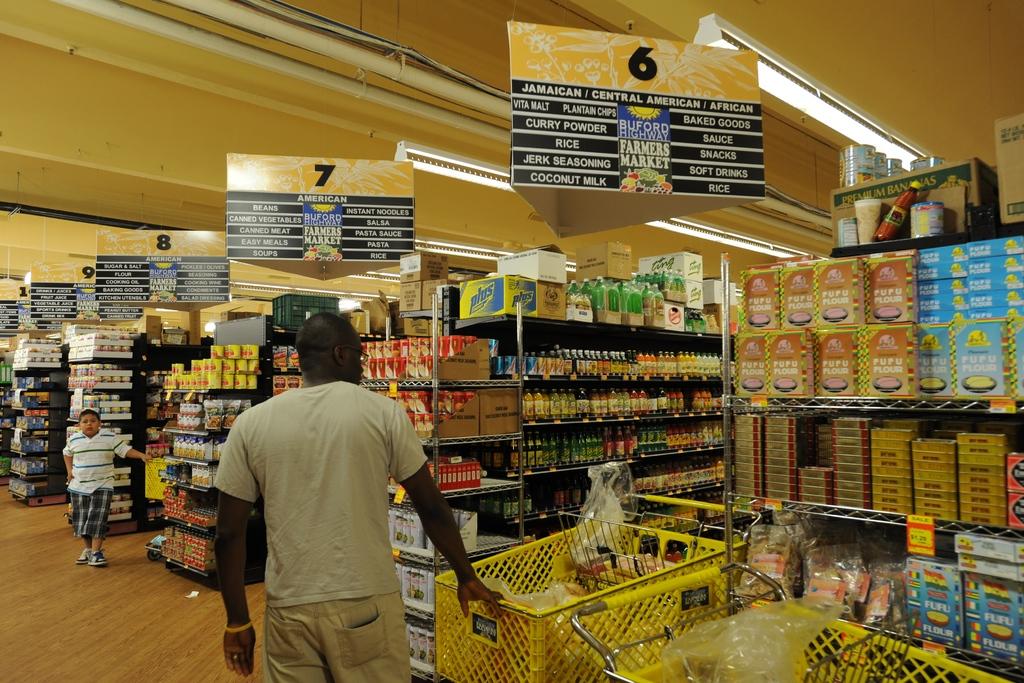What aisle number is the furthest away?
Provide a short and direct response. 10. 